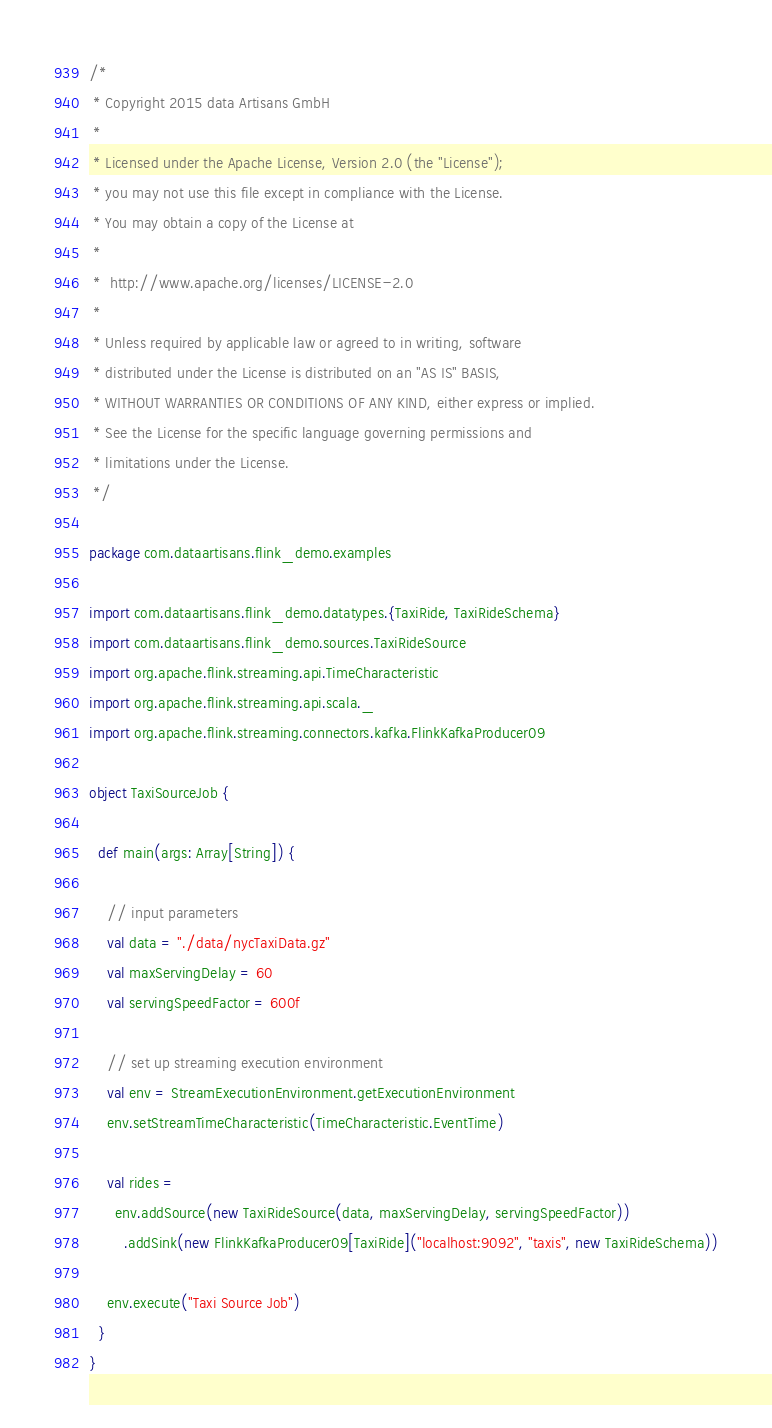Convert code to text. <code><loc_0><loc_0><loc_500><loc_500><_Scala_>/*
 * Copyright 2015 data Artisans GmbH
 *
 * Licensed under the Apache License, Version 2.0 (the "License");
 * you may not use this file except in compliance with the License.
 * You may obtain a copy of the License at
 *
 *  http://www.apache.org/licenses/LICENSE-2.0
 *
 * Unless required by applicable law or agreed to in writing, software
 * distributed under the License is distributed on an "AS IS" BASIS,
 * WITHOUT WARRANTIES OR CONDITIONS OF ANY KIND, either express or implied.
 * See the License for the specific language governing permissions and
 * limitations under the License.
 */

package com.dataartisans.flink_demo.examples

import com.dataartisans.flink_demo.datatypes.{TaxiRide, TaxiRideSchema}
import com.dataartisans.flink_demo.sources.TaxiRideSource
import org.apache.flink.streaming.api.TimeCharacteristic
import org.apache.flink.streaming.api.scala._
import org.apache.flink.streaming.connectors.kafka.FlinkKafkaProducer09

object TaxiSourceJob {

  def main(args: Array[String]) {

    // input parameters
    val data = "./data/nycTaxiData.gz"
    val maxServingDelay = 60
    val servingSpeedFactor = 600f

    // set up streaming execution environment
    val env = StreamExecutionEnvironment.getExecutionEnvironment
    env.setStreamTimeCharacteristic(TimeCharacteristic.EventTime)

    val rides =
      env.addSource(new TaxiRideSource(data, maxServingDelay, servingSpeedFactor))
        .addSink(new FlinkKafkaProducer09[TaxiRide]("localhost:9092", "taxis", new TaxiRideSchema))

    env.execute("Taxi Source Job")
  }
}


</code> 